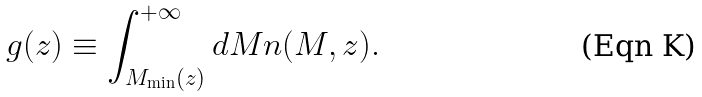Convert formula to latex. <formula><loc_0><loc_0><loc_500><loc_500>g ( z ) \equiv \int _ { M _ { \min } ( z ) } ^ { + \infty } d M n ( M , z ) .</formula> 